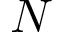<formula> <loc_0><loc_0><loc_500><loc_500>N</formula> 